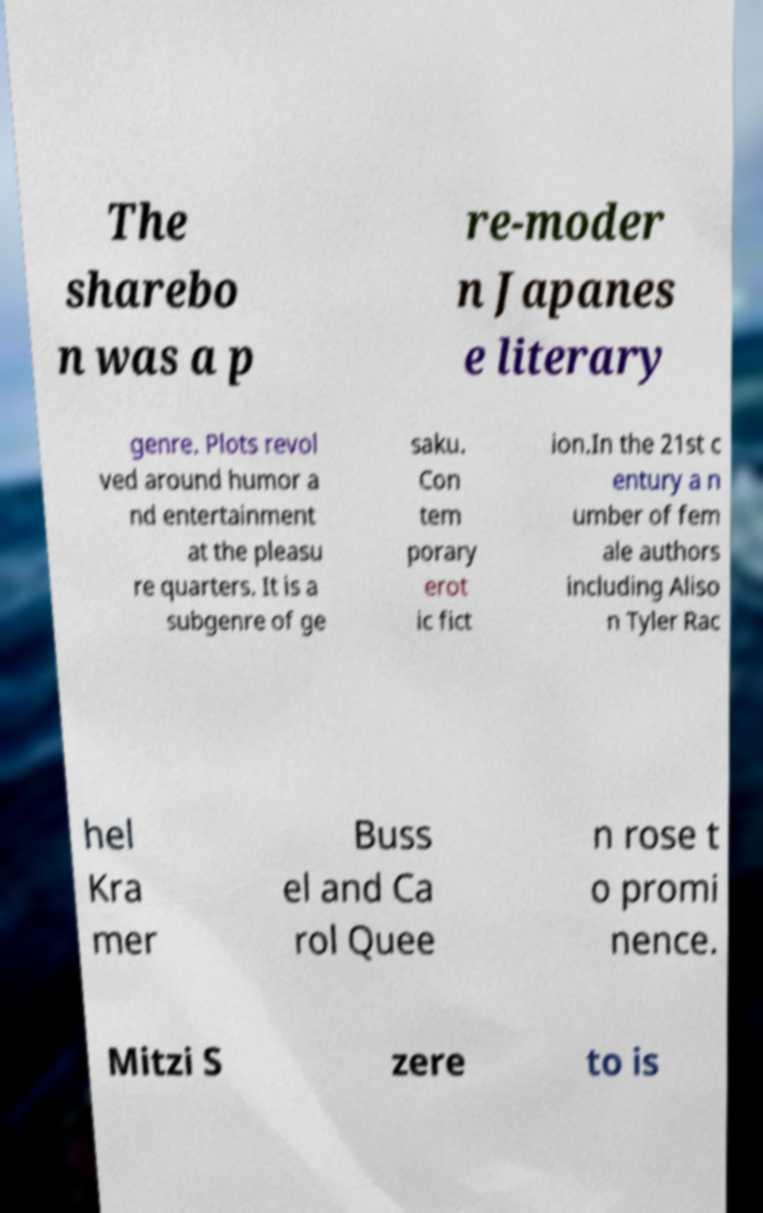Could you extract and type out the text from this image? The sharebo n was a p re-moder n Japanes e literary genre. Plots revol ved around humor a nd entertainment at the pleasu re quarters. It is a subgenre of ge saku. Con tem porary erot ic fict ion.In the 21st c entury a n umber of fem ale authors including Aliso n Tyler Rac hel Kra mer Buss el and Ca rol Quee n rose t o promi nence. Mitzi S zere to is 